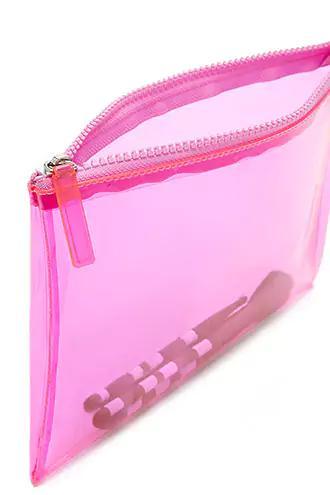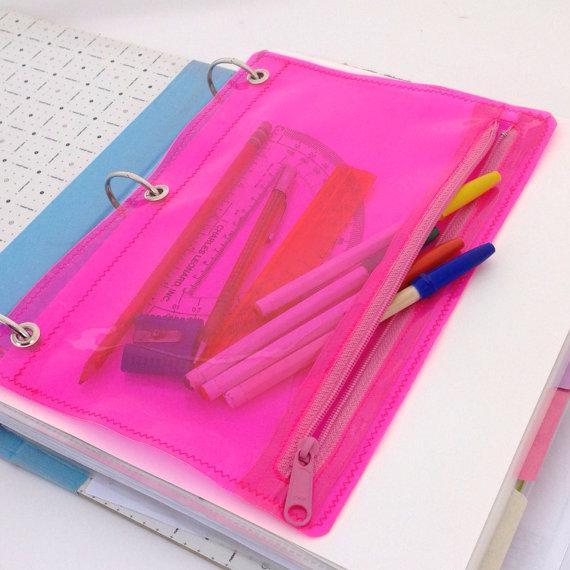The first image is the image on the left, the second image is the image on the right. Considering the images on both sides, is "One image shows a closed hard-sided pencil case with a big-eyed cartoon girl on the front, and the other shows an open pink-and-white case." valid? Answer yes or no. No. The first image is the image on the left, the second image is the image on the right. Considering the images on both sides, is "At least one of the pencil cases opens and closes with a zipper." valid? Answer yes or no. Yes. 